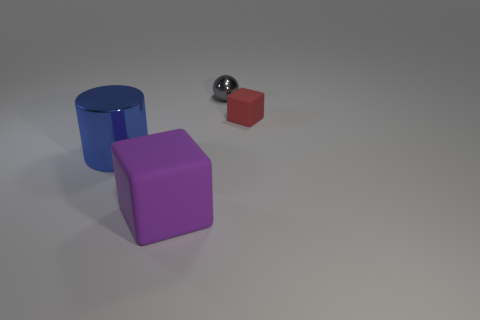How many matte objects are either tiny brown balls or tiny things?
Your response must be concise. 1. Is the size of the blue cylinder the same as the purple cube?
Provide a short and direct response. Yes. How many things are small metal objects or things on the right side of the blue shiny thing?
Your answer should be compact. 3. There is a block that is the same size as the blue thing; what material is it?
Provide a succinct answer. Rubber. There is a thing that is to the left of the tiny matte object and to the right of the big purple matte block; what is it made of?
Make the answer very short. Metal. Are there any metal objects that are behind the matte block behind the big blue metal cylinder?
Make the answer very short. Yes. What is the size of the object that is to the left of the small gray thing and on the right side of the blue object?
Keep it short and to the point. Large. How many blue objects are big shiny cylinders or metal things?
Make the answer very short. 1. The red matte object that is the same size as the sphere is what shape?
Make the answer very short. Cube. How many other things are there of the same color as the big rubber block?
Keep it short and to the point. 0. 